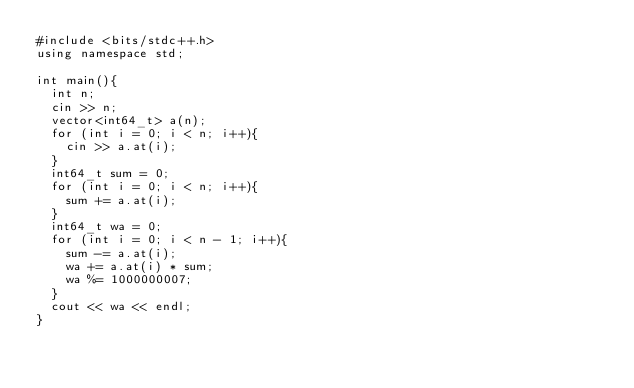Convert code to text. <code><loc_0><loc_0><loc_500><loc_500><_C++_>#include <bits/stdc++.h>
using namespace std;

int main(){
  int n;
  cin >> n;
  vector<int64_t> a(n);
  for (int i = 0; i < n; i++){
    cin >> a.at(i);
  }
  int64_t sum = 0;
  for (int i = 0; i < n; i++){
    sum += a.at(i);
  }
  int64_t wa = 0;
  for (int i = 0; i < n - 1; i++){
    sum -= a.at(i);
    wa += a.at(i) * sum;
    wa %= 1000000007;
  }
  cout << wa << endl;
}</code> 